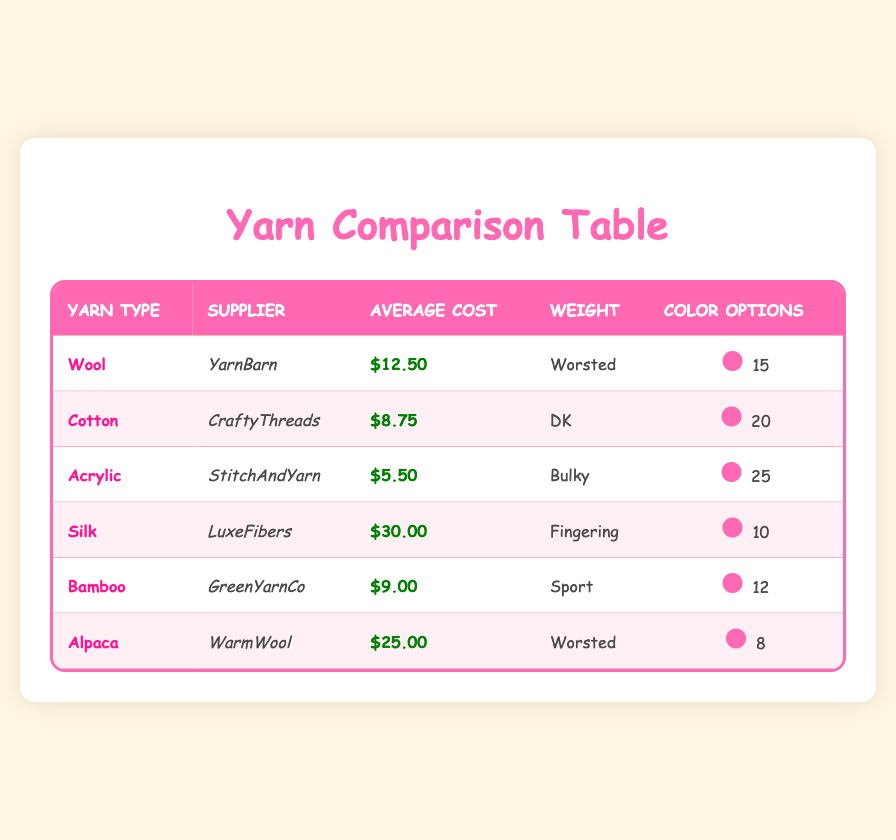What is the average cost of Wool yarn from YarnBarn? The average cost per skein of Wool yarn from YarnBarn is listed as $12.50 in the table.
Answer: $12.50 How many color options does Acrylic yarn have? The table shows that Acrylic yarn, supplied by StitchAndYarn, has 25 color options available.
Answer: 25 Which supplier offers the lowest average cost of yarn? By reviewing the average costs listed for each supplier, StitchAndYarn offers the lowest average cost at $5.50 for Acrylic yarn.
Answer: StitchAndYarn What is the total average cost of the yarn types: Wool, Cotton, and Bamboo? Add the average costs of Wool ($12.50), Cotton ($8.75), and Bamboo ($9.00) together: 12.50 + 8.75 + 9.00 = 30.25. The total average cost is $30.25.
Answer: $30.25 Is it true that Silk yarn has more color options than Wool yarn? Silk yarn has 10 color options while Wool yarn has 15. Therefore, it is false that Silk yarn has more color options than Wool yarn.
Answer: No Which yarn type has the highest average cost and how much is it? The table indicates that Silk yarn has the highest average cost at $30.00 per skein among all the yarn types listed.
Answer: Silk, $30.00 If you were to purchase one skein each of Alpaca and Bamboo yarn, what would be the total cost? The average cost of Alpaca yarn is $25.00 and Bamboo yarn is $9.00. Adding these together gives: 25.00 + 9.00 = 34.00, so the total cost would be $34.00.
Answer: $34.00 How many more color options does Acrylic yarn have compared to Bamboo yarn? Acrylic yarn has 25 color options while Bamboo yarn has 12. The difference in color options is 25 - 12 = 13. Therefore, Acrylic yarn has 13 more color options than Bamboo yarn.
Answer: 13 From which supplier can you get the most expensive yarn, and what is the yarn type? The table displays that LuxeFibers supplies Silk yarn at the highest cost of $30.00 per skein, making it the most expensive option.
Answer: LuxeFibers, Silk 